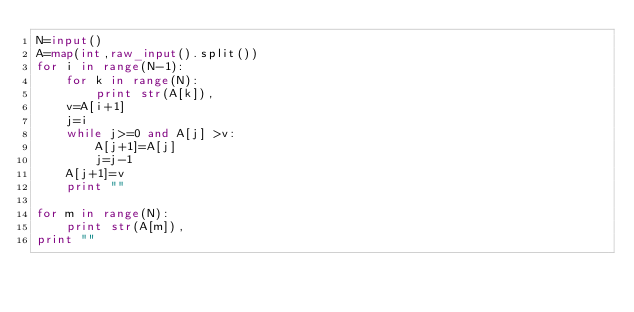<code> <loc_0><loc_0><loc_500><loc_500><_Python_>N=input()
A=map(int,raw_input().split())
for i in range(N-1):
	for k in range(N):
		print str(A[k]),
	v=A[i+1]
	j=i
	while j>=0 and A[j] >v:
		A[j+1]=A[j]
		j=j-1
	A[j+1]=v
	print ""

for m in range(N):
	print str(A[m]),
print ""</code> 